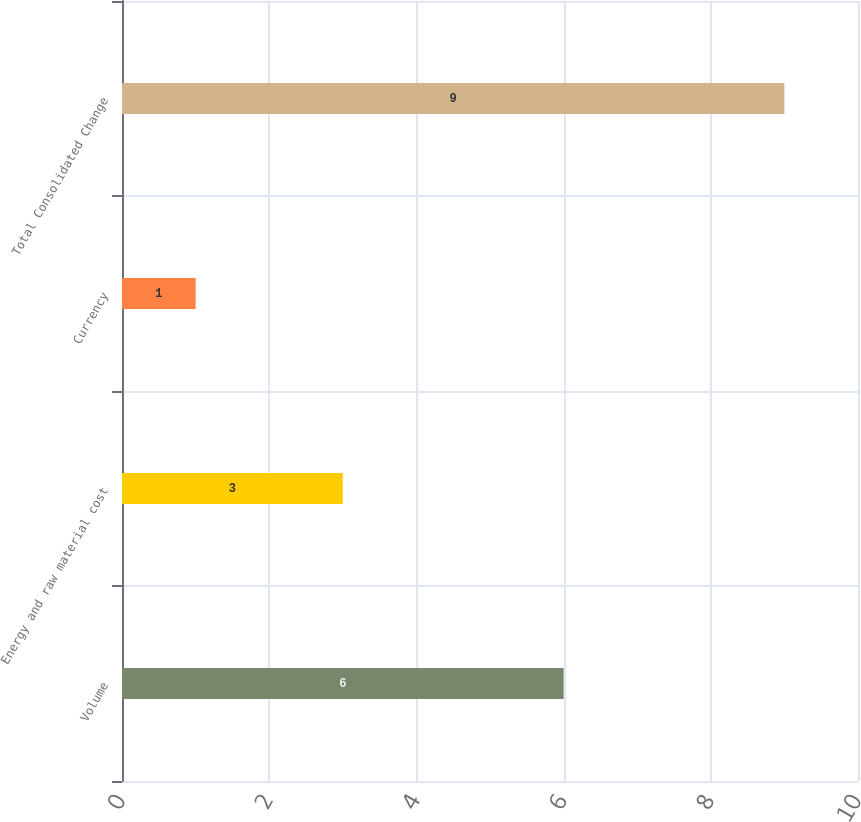Convert chart. <chart><loc_0><loc_0><loc_500><loc_500><bar_chart><fcel>Volume<fcel>Energy and raw material cost<fcel>Currency<fcel>Total Consolidated Change<nl><fcel>6<fcel>3<fcel>1<fcel>9<nl></chart> 